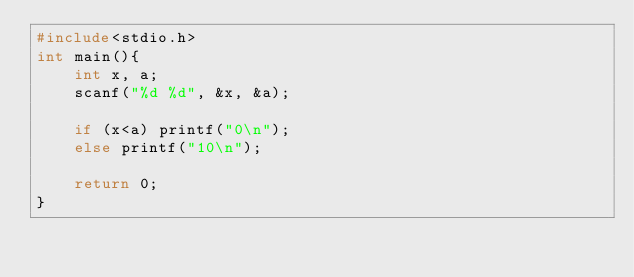Convert code to text. <code><loc_0><loc_0><loc_500><loc_500><_C_>#include<stdio.h>
int main(){
    int x, a;
    scanf("%d %d", &x, &a);
    
    if (x<a) printf("0\n");
    else printf("10\n");
    
    return 0;
}</code> 